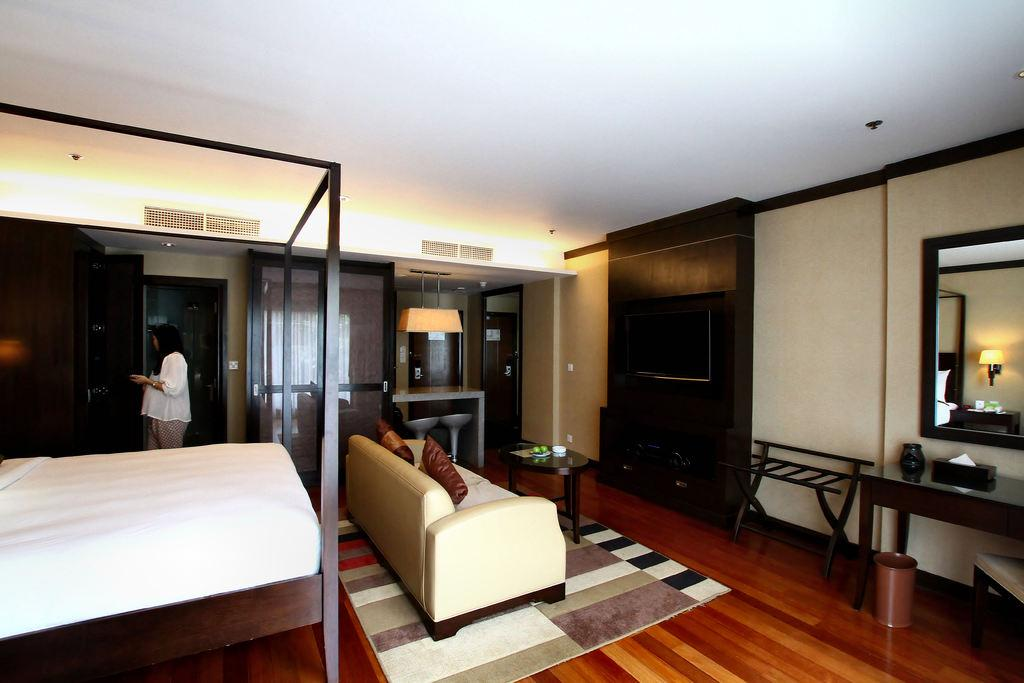What is the main subject in the image? There is a woman standing in the image. Where is the woman standing? The woman is standing on the floor. What furniture can be seen in the image? There is a bed, a couch, a mirror, and a table in the image. What type of deer can be seen in the mirror in the image? There is no deer present in the image, and therefore it cannot be seen in the mirror. 